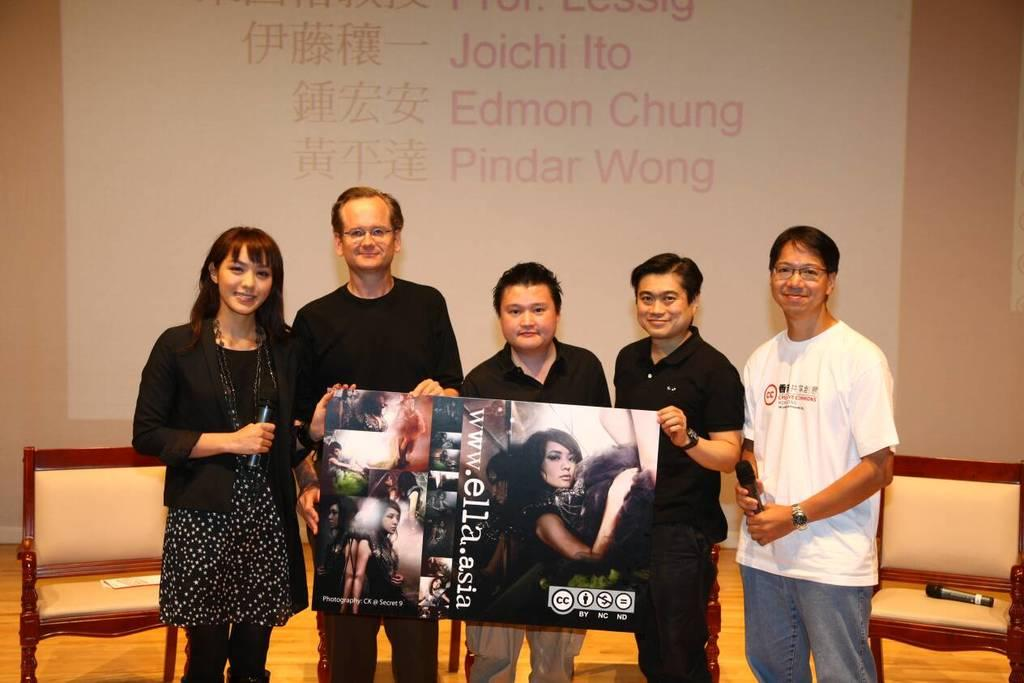How many people are present in the image? There are five people standing in the image. What are the people holding in the image? The people are holding a sheet in the image. What is depicted on the sheet? There is a woman depicted on the sheet. What else can be seen in the image besides the people and the sheet? There is a banner visible in the image. What type of garden can be seen in the background of the image? There is no garden visible in the image. 